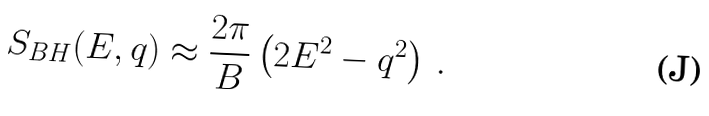Convert formula to latex. <formula><loc_0><loc_0><loc_500><loc_500>S _ { B H } ( E , q ) \approx \frac { 2 \pi } { B } \left ( 2 E ^ { 2 } - q ^ { 2 } \right ) \, .</formula> 